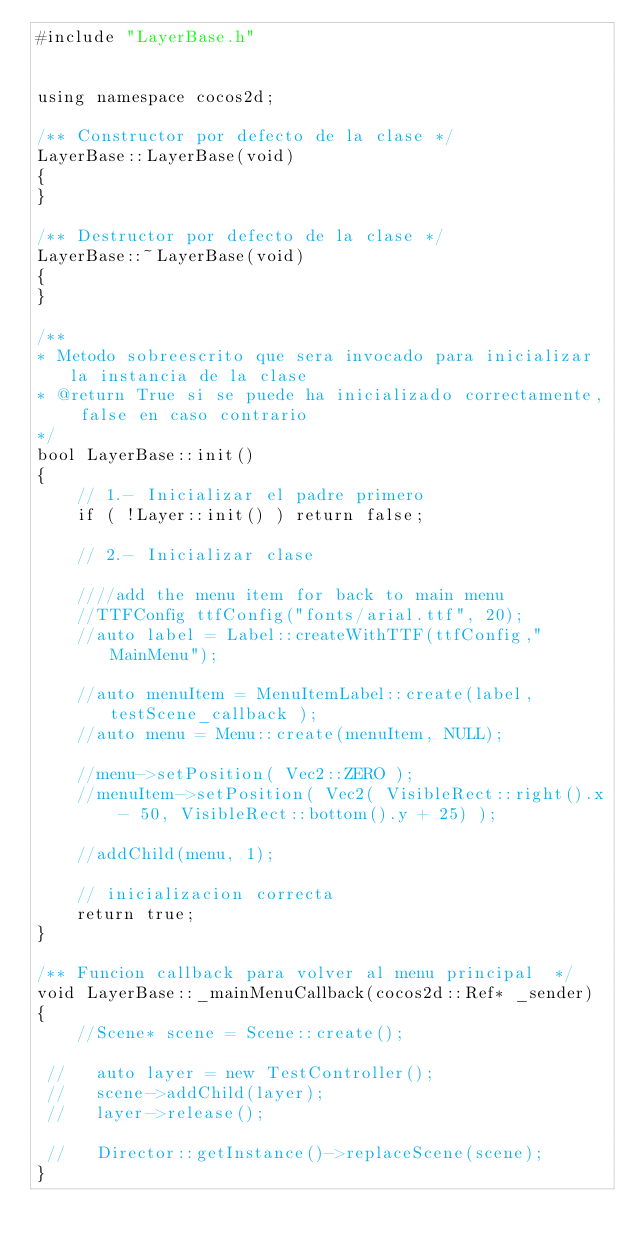Convert code to text. <code><loc_0><loc_0><loc_500><loc_500><_C++_>#include "LayerBase.h"


using namespace cocos2d;

/** Constructor por defecto de la clase */
LayerBase::LayerBase(void)
{
}

/** Destructor por defecto de la clase */
LayerBase::~LayerBase(void)
{
}

/** 
* Metodo sobreescrito que sera invocado para inicializar la instancia de la clase
* @return True si se puede ha inicializado correctamente, false en caso contrario
*/
bool LayerBase::init()
{
	// 1.- Inicializar el padre primero
	if ( !Layer::init() ) return false;

	// 2.- Inicializar clase

    ////add the menu item for back to main menu
    //TTFConfig ttfConfig("fonts/arial.ttf", 20);
    //auto label = Label::createWithTTF(ttfConfig,"MainMenu");

    //auto menuItem = MenuItemLabel::create(label, testScene_callback );
    //auto menu = Menu::create(menuItem, NULL);

    //menu->setPosition( Vec2::ZERO );
    //menuItem->setPosition( Vec2( VisibleRect::right().x - 50, VisibleRect::bottom().y + 25) );

    //addChild(menu, 1);

	// inicializacion correcta
	return true;
}	

/** Funcion callback para volver al menu principal 	*/
void LayerBase::_mainMenuCallback(cocos2d::Ref* _sender)
{
	//Scene* scene = Scene::create();

 //   auto layer = new TestController();
 //   scene->addChild(layer);
 //   layer->release();

 //   Director::getInstance()->replaceScene(scene);
}</code> 